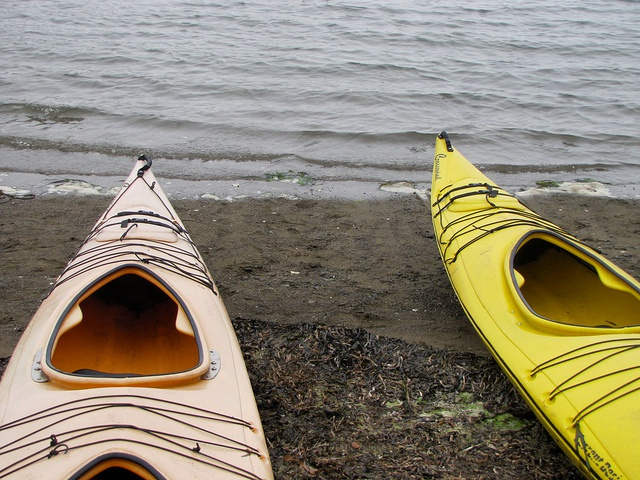Describe the objects in this image and their specific colors. I can see boat in darkgray, lightgray, tan, black, and maroon tones and boat in darkgray, khaki, gold, black, and olive tones in this image. 